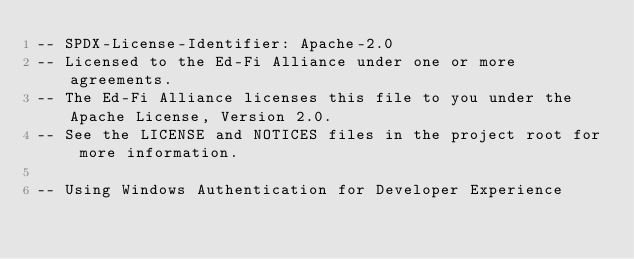Convert code to text. <code><loc_0><loc_0><loc_500><loc_500><_SQL_>-- SPDX-License-Identifier: Apache-2.0
-- Licensed to the Ed-Fi Alliance under one or more agreements.
-- The Ed-Fi Alliance licenses this file to you under the Apache License, Version 2.0.
-- See the LICENSE and NOTICES files in the project root for more information.

-- Using Windows Authentication for Developer Experience</code> 